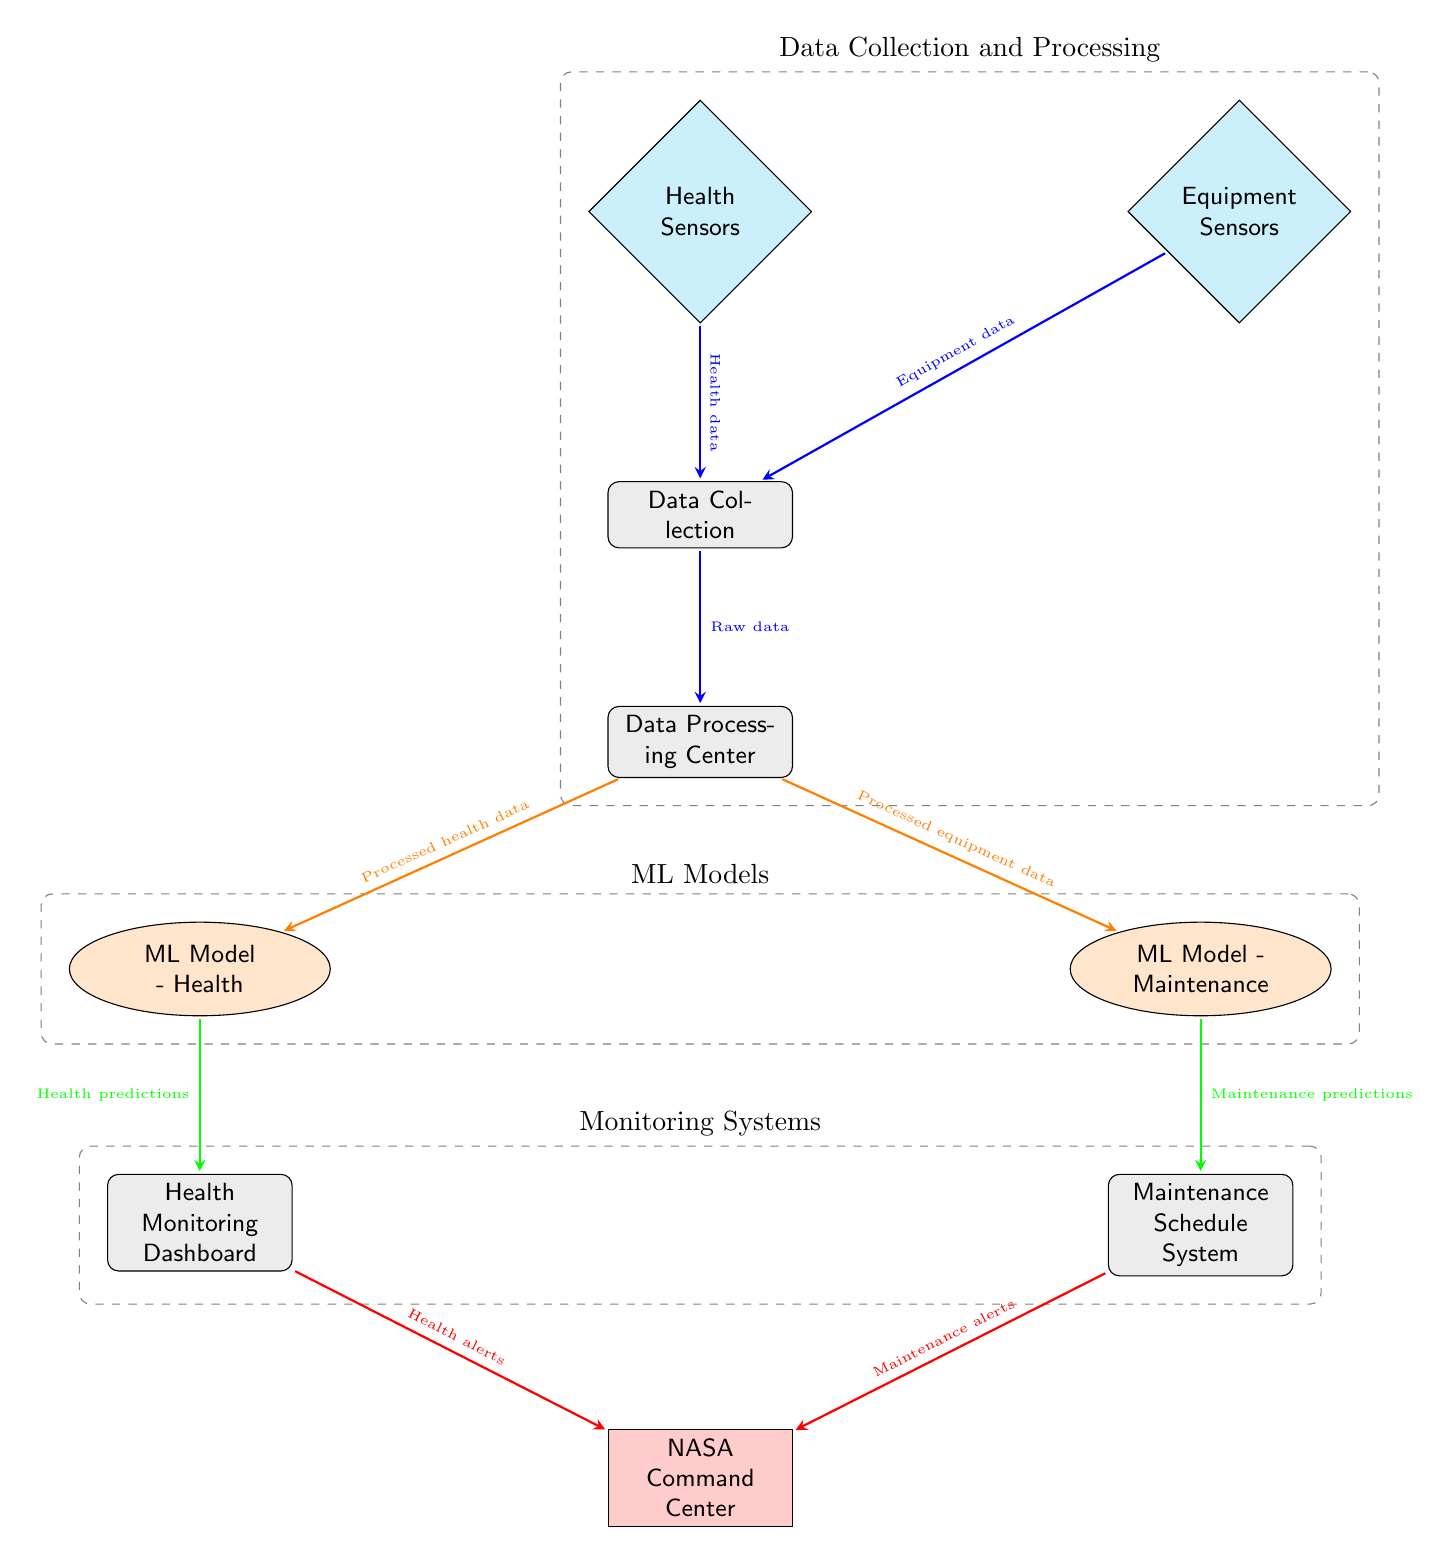What nodes are included in the Health Monitoring section? The Health Monitoring section is represented by the 'Health Monitoring Dashboard' node and flows from the 'ML Model - Health' node. It receives 'Health predictions' from the model, indicating that both nodes are part of this section.
Answer: Health Monitoring Dashboard How many sensor nodes are present in the diagram? There are two sensor nodes identified in the diagram: 'Health Sensors' and 'Equipment Sensors.' Each contributes specific data for monitoring purposes.
Answer: 2 What type of data does the Data Processing Center handle? The Data Processing Center is connected to both 'Health Sensors' and 'Equipment Sensors,' indicating that it processes both health data and equipment data, marking it as a mediator for these inputs.
Answer: Processed health data, Processed equipment data Which system receives alerts from the Health Monitoring Dashboard? The 'NASA Command Center' receives alerts, as represented in the diagram by an arrow that flows from the 'Health Monitoring Dashboard,' linking it directly to this control center.
Answer: NASA Command Center What is the outcome of the ML Model - Maintenance? The output of the 'ML Model - Maintenance' is 'Maintenance predictions,' which feeds into the 'Maintenance Schedule System,' emphasizing its role in predictive maintenance.
Answer: Maintenance predictions How does equipment data reach the Maintenance Schedule System? Equipment data initially flows from 'Equipment Sensors' through the 'Data Collection' and 'Data Processing Center,' ultimately leading to the 'ML Model - Maintenance,' which generates predictions that are routed to the 'Maintenance Schedule System.'
Answer: Through Data Collection and Processing Center What distinguishes the ML Models section in the diagram? The ML Models section includes two nodes: 'ML Model - Health' and 'ML Model - Maintenance,' both derived from processed data, specifically tailored for health monitoring and maintenance scheduling.
Answer: Two ML Models What alerts are sent to the NASA Command Center? The NASA Command Center receives both 'Health alerts' from the 'Health Monitoring Dashboard' and 'Maintenance alerts' from the 'Maintenance Schedule System,' highlighting its comprehensive oversight role.
Answer: Health alerts, Maintenance alerts 